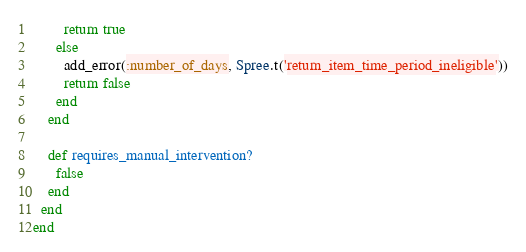<code> <loc_0><loc_0><loc_500><loc_500><_Ruby_>        return true
      else
        add_error(:number_of_days, Spree.t('return_item_time_period_ineligible'))
        return false
      end
    end

    def requires_manual_intervention?
      false
    end
  end
end
</code> 